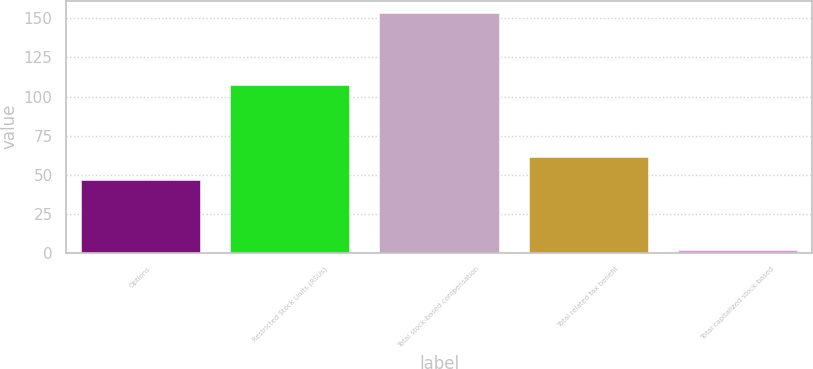Convert chart to OTSL. <chart><loc_0><loc_0><loc_500><loc_500><bar_chart><fcel>Options<fcel>Restricted Stock Units (RSUs)<fcel>Total stock-based compensation<fcel>Total related tax benefit<fcel>Total capitalized stock-based<nl><fcel>46.2<fcel>107.4<fcel>153.6<fcel>61.36<fcel>2<nl></chart> 